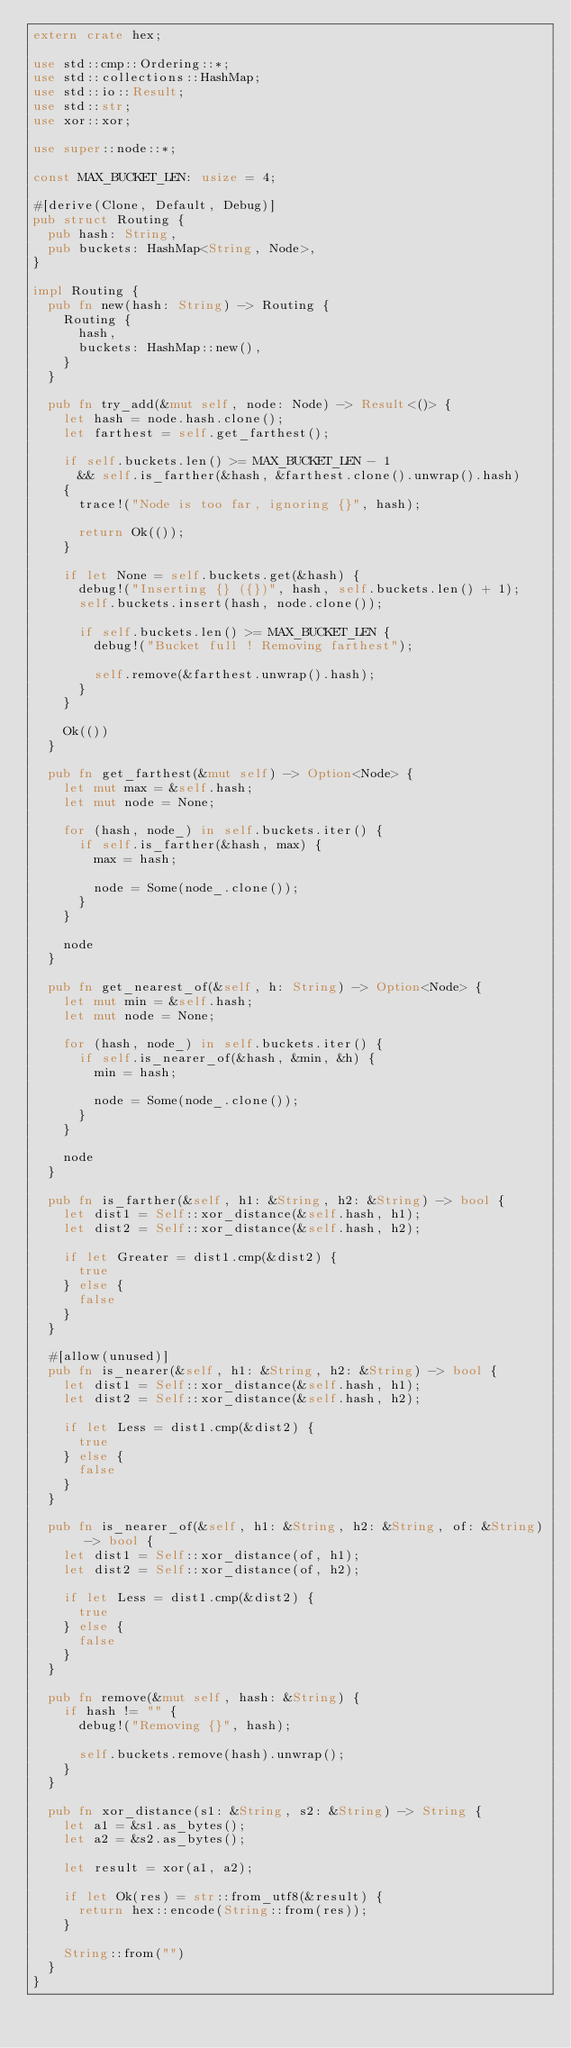Convert code to text. <code><loc_0><loc_0><loc_500><loc_500><_Rust_>extern crate hex;

use std::cmp::Ordering::*;
use std::collections::HashMap;
use std::io::Result;
use std::str;
use xor::xor;

use super::node::*;

const MAX_BUCKET_LEN: usize = 4;

#[derive(Clone, Default, Debug)]
pub struct Routing {
  pub hash: String,
  pub buckets: HashMap<String, Node>,
}

impl Routing {
  pub fn new(hash: String) -> Routing {
    Routing {
      hash,
      buckets: HashMap::new(),
    }
  }

  pub fn try_add(&mut self, node: Node) -> Result<()> {
    let hash = node.hash.clone();
    let farthest = self.get_farthest();

    if self.buckets.len() >= MAX_BUCKET_LEN - 1
      && self.is_farther(&hash, &farthest.clone().unwrap().hash)
    {
      trace!("Node is too far, ignoring {}", hash);

      return Ok(());
    }

    if let None = self.buckets.get(&hash) {
      debug!("Inserting {} ({})", hash, self.buckets.len() + 1);
      self.buckets.insert(hash, node.clone());

      if self.buckets.len() >= MAX_BUCKET_LEN {
        debug!("Bucket full ! Removing farthest");

        self.remove(&farthest.unwrap().hash);
      }
    }

    Ok(())
  }

  pub fn get_farthest(&mut self) -> Option<Node> {
    let mut max = &self.hash;
    let mut node = None;

    for (hash, node_) in self.buckets.iter() {
      if self.is_farther(&hash, max) {
        max = hash;

        node = Some(node_.clone());
      }
    }

    node
  }

  pub fn get_nearest_of(&self, h: String) -> Option<Node> {
    let mut min = &self.hash;
    let mut node = None;

    for (hash, node_) in self.buckets.iter() {
      if self.is_nearer_of(&hash, &min, &h) {
        min = hash;

        node = Some(node_.clone());
      }
    }

    node
  }

  pub fn is_farther(&self, h1: &String, h2: &String) -> bool {
    let dist1 = Self::xor_distance(&self.hash, h1);
    let dist2 = Self::xor_distance(&self.hash, h2);

    if let Greater = dist1.cmp(&dist2) {
      true
    } else {
      false
    }
  }

  #[allow(unused)]
  pub fn is_nearer(&self, h1: &String, h2: &String) -> bool {
    let dist1 = Self::xor_distance(&self.hash, h1);
    let dist2 = Self::xor_distance(&self.hash, h2);

    if let Less = dist1.cmp(&dist2) {
      true
    } else {
      false
    }
  }

  pub fn is_nearer_of(&self, h1: &String, h2: &String, of: &String) -> bool {
    let dist1 = Self::xor_distance(of, h1);
    let dist2 = Self::xor_distance(of, h2);

    if let Less = dist1.cmp(&dist2) {
      true
    } else {
      false
    }
  }

  pub fn remove(&mut self, hash: &String) {
    if hash != "" {
      debug!("Removing {}", hash);

      self.buckets.remove(hash).unwrap();
    }
  }

  pub fn xor_distance(s1: &String, s2: &String) -> String {
    let a1 = &s1.as_bytes();
    let a2 = &s2.as_bytes();

    let result = xor(a1, a2);

    if let Ok(res) = str::from_utf8(&result) {
      return hex::encode(String::from(res));
    }

    String::from("")
  }
}
</code> 